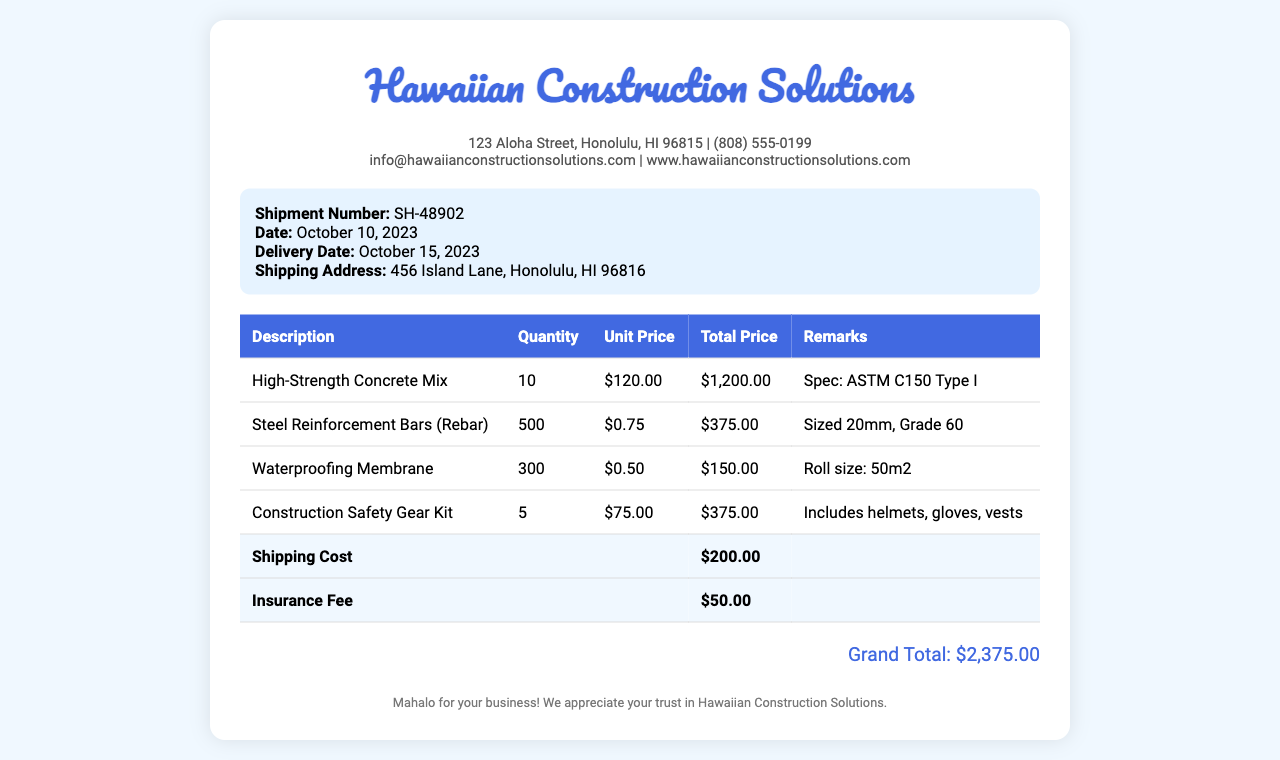What is the shipment number? The shipment number is specifically labeled in the document, which is SH-48902.
Answer: SH-48902 What is the total cost of the High-Strength Concrete Mix? The total cost of the High-Strength Concrete Mix can be found in the itemized costs section, which is $1,200.00.
Answer: $1,200.00 How many Steel Reinforcement Bars were ordered? The quantity of Steel Reinforcement Bars is given in the document as 500.
Answer: 500 What is the delivery date? The delivery date is explicitly stated in the shipment details, which is October 15, 2023.
Answer: October 15, 2023 What is the grand total amount? The grand total amount is summarized at the end of the document, which is $2,375.00.
Answer: $2,375.00 How much was the shipping cost? The shipping cost is detailed in the itemized costs as $200.00.
Answer: $200.00 What type of safety gear is included in the Construction Safety Gear Kit? The included items in the Construction Safety Gear Kit are mentioned in the remarks, which include helmets, gloves, and vests.
Answer: helmets, gloves, vests What is the date of the receipt? The date of the receipt is indicated in the shipment details as October 10, 2023.
Answer: October 10, 2023 What is the address for delivery? The shipping address is specifically provided in the document, which is 456 Island Lane, Honolulu, HI 96816.
Answer: 456 Island Lane, Honolulu, HI 96816 